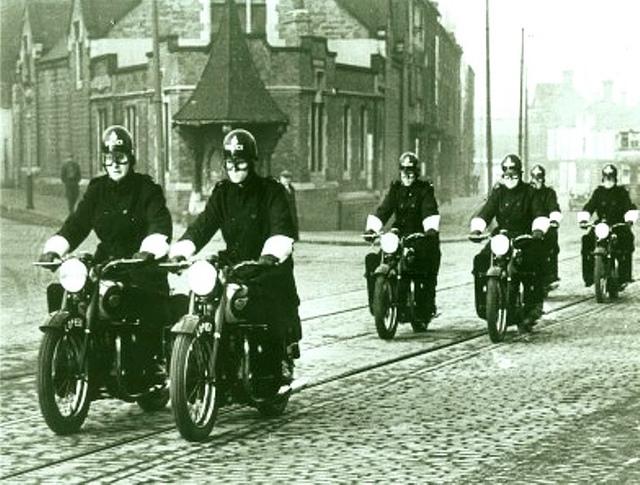Why are they riding in pairs?
Keep it brief. Travel closer. Are this policemen?
Keep it brief. Yes. What are they riding on?
Give a very brief answer. Motorcycles. 